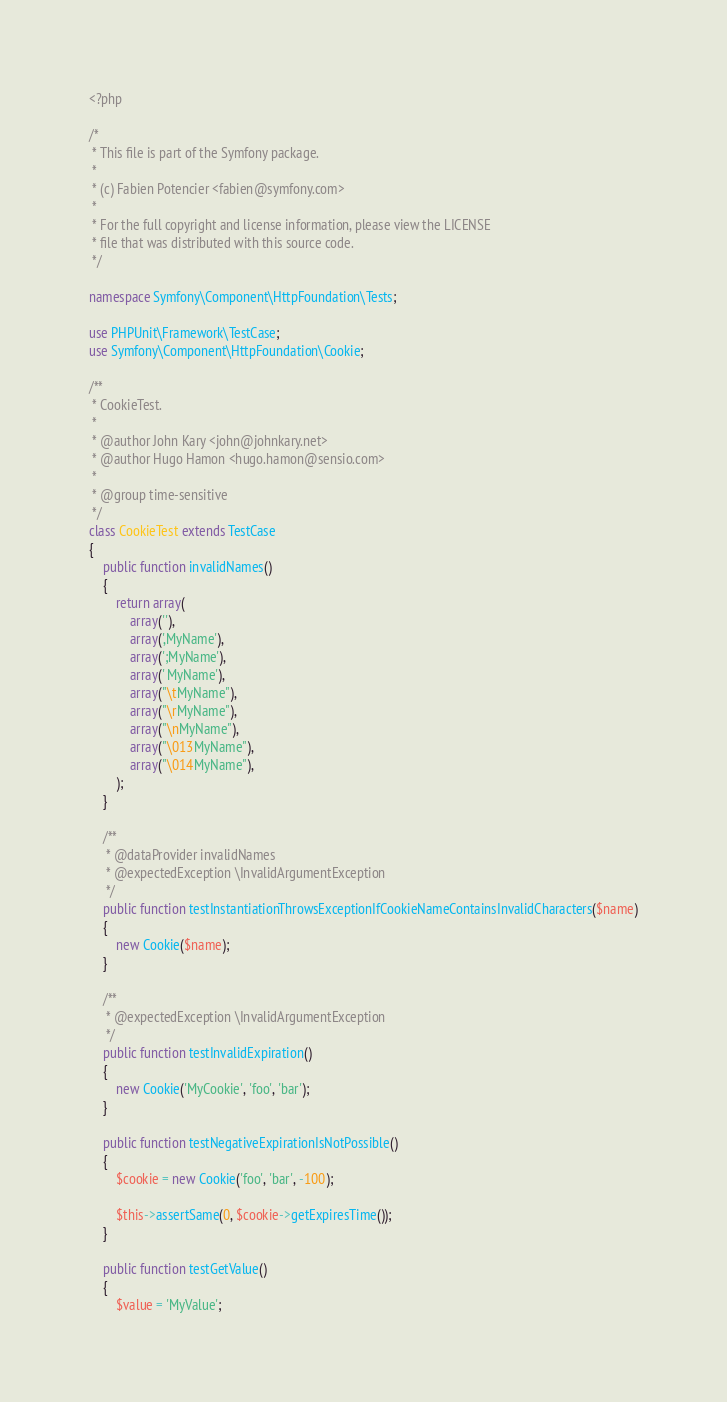Convert code to text. <code><loc_0><loc_0><loc_500><loc_500><_PHP_><?php

/*
 * This file is part of the Symfony package.
 *
 * (c) Fabien Potencier <fabien@symfony.com>
 *
 * For the full copyright and license information, please view the LICENSE
 * file that was distributed with this source code.
 */

namespace Symfony\Component\HttpFoundation\Tests;

use PHPUnit\Framework\TestCase;
use Symfony\Component\HttpFoundation\Cookie;

/**
 * CookieTest.
 *
 * @author John Kary <john@johnkary.net>
 * @author Hugo Hamon <hugo.hamon@sensio.com>
 *
 * @group time-sensitive
 */
class CookieTest extends TestCase
{
    public function invalidNames()
    {
        return array(
            array(''),
            array(',MyName'),
            array(';MyName'),
            array(' MyName'),
            array("\tMyName"),
            array("\rMyName"),
            array("\nMyName"),
            array("\013MyName"),
            array("\014MyName"),
        );
    }

    /**
     * @dataProvider invalidNames
     * @expectedException \InvalidArgumentException
     */
    public function testInstantiationThrowsExceptionIfCookieNameContainsInvalidCharacters($name)
    {
        new Cookie($name);
    }

    /**
     * @expectedException \InvalidArgumentException
     */
    public function testInvalidExpiration()
    {
        new Cookie('MyCookie', 'foo', 'bar');
    }

    public function testNegativeExpirationIsNotPossible()
    {
        $cookie = new Cookie('foo', 'bar', -100);

        $this->assertSame(0, $cookie->getExpiresTime());
    }

    public function testGetValue()
    {
        $value = 'MyValue';</code> 